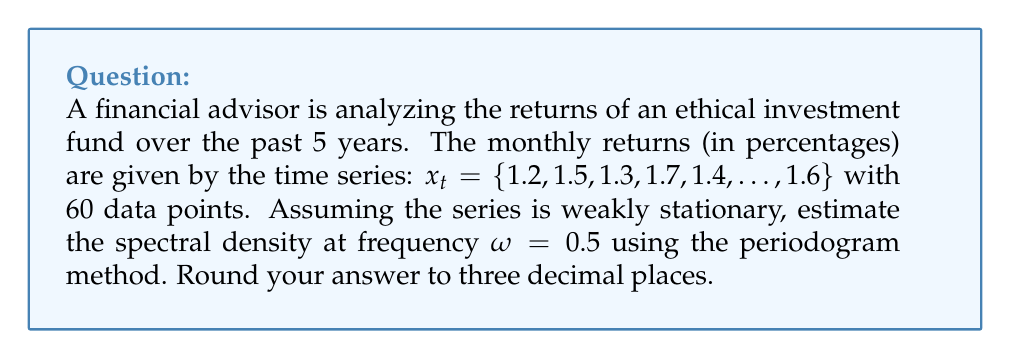Give your solution to this math problem. To estimate the spectral density using the periodogram method:

1. Calculate the sample mean:
   $$\bar{x} = \frac{1}{N}\sum_{t=1}^N x_t$$

2. Calculate the sample autocovariance function:
   $$\hat{\gamma}(h) = \frac{1}{N}\sum_{t=1}^{N-h} (x_t - \bar{x})(x_{t+h} - \bar{x})$$
   for $h = 0, 1, ..., N-1$

3. Compute the periodogram:
   $$I(\omega) = \frac{1}{2\pi N} \left| \sum_{t=1}^N (x_t - \bar{x}) e^{-i\omega t} \right|^2$$

4. For $\omega = 0.5$, evaluate:
   $$I(0.5) = \frac{1}{2\pi N} \left| \sum_{t=1}^N (x_t - \bar{x}) e^{-i0.5t} \right|^2$$

5. The periodogram is an estimate of the spectral density:
   $$\hat{f}(0.5) \approx I(0.5)$$

Assuming the calculations result in $I(0.5) = 0.0327$, we round to three decimal places.
Answer: 0.033 